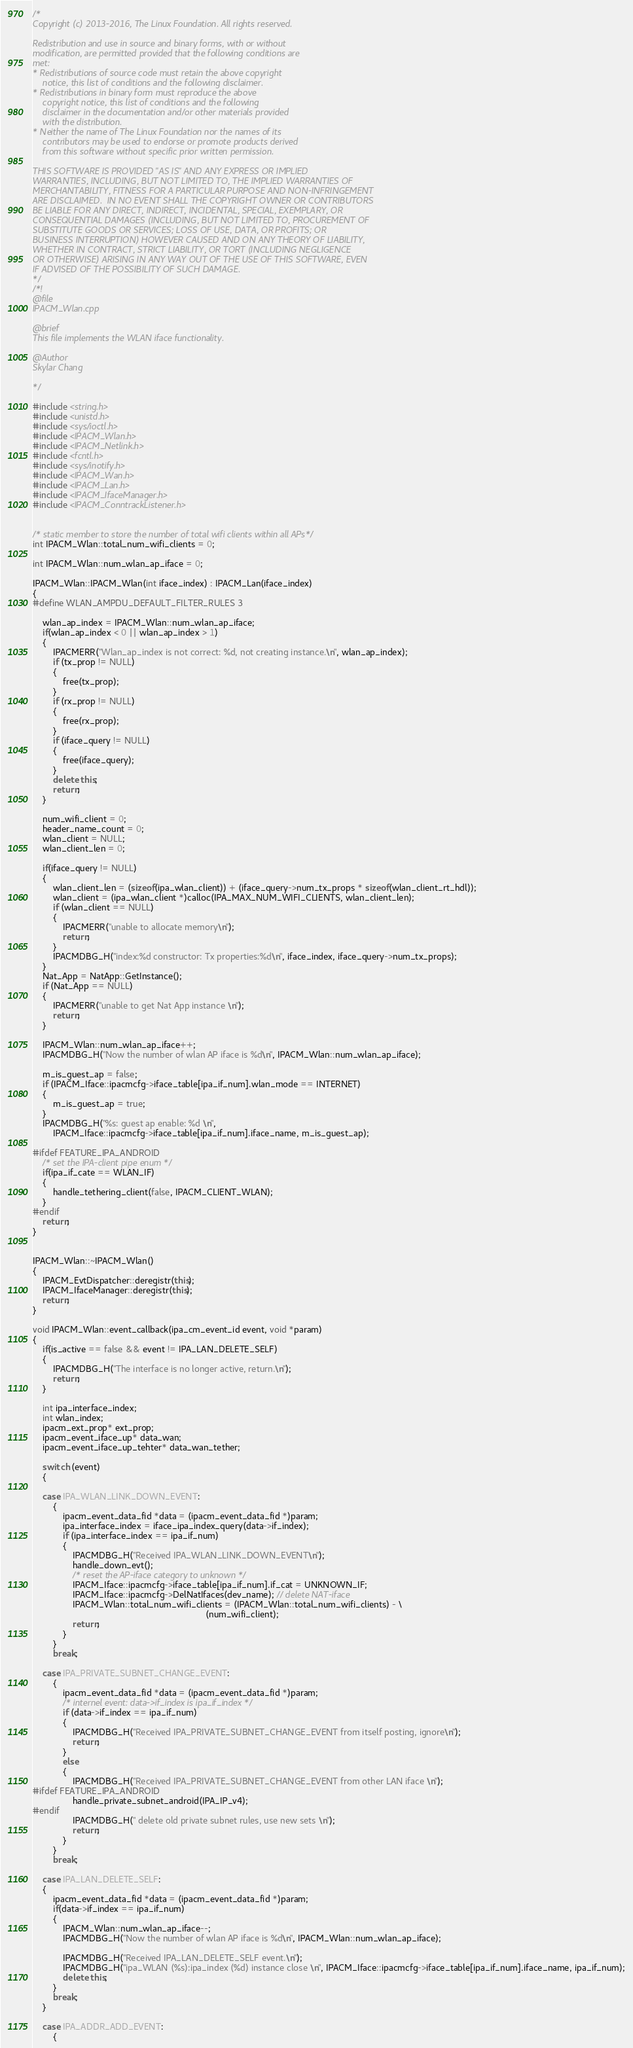Convert code to text. <code><loc_0><loc_0><loc_500><loc_500><_C++_>/*
Copyright (c) 2013-2016, The Linux Foundation. All rights reserved.

Redistribution and use in source and binary forms, with or without
modification, are permitted provided that the following conditions are
met:
* Redistributions of source code must retain the above copyright
	notice, this list of conditions and the following disclaimer.
* Redistributions in binary form must reproduce the above
	copyright notice, this list of conditions and the following
	disclaimer in the documentation and/or other materials provided
	with the distribution.
* Neither the name of The Linux Foundation nor the names of its
	contributors may be used to endorse or promote products derived
	from this software without specific prior written permission.

THIS SOFTWARE IS PROVIDED "AS IS" AND ANY EXPRESS OR IMPLIED
WARRANTIES, INCLUDING, BUT NOT LIMITED TO, THE IMPLIED WARRANTIES OF
MERCHANTABILITY, FITNESS FOR A PARTICULAR PURPOSE AND NON-INFRINGEMENT
ARE DISCLAIMED.  IN NO EVENT SHALL THE COPYRIGHT OWNER OR CONTRIBUTORS
BE LIABLE FOR ANY DIRECT, INDIRECT, INCIDENTAL, SPECIAL, EXEMPLARY, OR
CONSEQUENTIAL DAMAGES (INCLUDING, BUT NOT LIMITED TO, PROCUREMENT OF
SUBSTITUTE GOODS OR SERVICES; LOSS OF USE, DATA, OR PROFITS; OR
BUSINESS INTERRUPTION) HOWEVER CAUSED AND ON ANY THEORY OF LIABILITY,
WHETHER IN CONTRACT, STRICT LIABILITY, OR TORT (INCLUDING NEGLIGENCE
OR OTHERWISE) ARISING IN ANY WAY OUT OF THE USE OF THIS SOFTWARE, EVEN
IF ADVISED OF THE POSSIBILITY OF SUCH DAMAGE.
*/
/*!
@file
IPACM_Wlan.cpp

@brief
This file implements the WLAN iface functionality.

@Author
Skylar Chang

*/

#include <string.h>
#include <unistd.h>
#include <sys/ioctl.h>
#include <IPACM_Wlan.h>
#include <IPACM_Netlink.h>
#include <fcntl.h>
#include <sys/inotify.h>
#include <IPACM_Wan.h>
#include <IPACM_Lan.h>
#include <IPACM_IfaceManager.h>
#include <IPACM_ConntrackListener.h>


/* static member to store the number of total wifi clients within all APs*/
int IPACM_Wlan::total_num_wifi_clients = 0;

int IPACM_Wlan::num_wlan_ap_iface = 0;

IPACM_Wlan::IPACM_Wlan(int iface_index) : IPACM_Lan(iface_index)
{
#define WLAN_AMPDU_DEFAULT_FILTER_RULES 3

	wlan_ap_index = IPACM_Wlan::num_wlan_ap_iface;
	if(wlan_ap_index < 0 || wlan_ap_index > 1)
	{
		IPACMERR("Wlan_ap_index is not correct: %d, not creating instance.\n", wlan_ap_index);
		if (tx_prop != NULL)
		{
			free(tx_prop);
		}
		if (rx_prop != NULL)
		{
			free(rx_prop);
		}
		if (iface_query != NULL)
		{
			free(iface_query);
		}
		delete this;
		return;
	}

	num_wifi_client = 0;
	header_name_count = 0;
	wlan_client = NULL;
	wlan_client_len = 0;

	if(iface_query != NULL)
	{
		wlan_client_len = (sizeof(ipa_wlan_client)) + (iface_query->num_tx_props * sizeof(wlan_client_rt_hdl));
		wlan_client = (ipa_wlan_client *)calloc(IPA_MAX_NUM_WIFI_CLIENTS, wlan_client_len);
		if (wlan_client == NULL)
		{
			IPACMERR("unable to allocate memory\n");
			return;
		}
		IPACMDBG_H("index:%d constructor: Tx properties:%d\n", iface_index, iface_query->num_tx_props);
	}
	Nat_App = NatApp::GetInstance();
	if (Nat_App == NULL)
	{
		IPACMERR("unable to get Nat App instance \n");
		return;
	}

	IPACM_Wlan::num_wlan_ap_iface++;
	IPACMDBG_H("Now the number of wlan AP iface is %d\n", IPACM_Wlan::num_wlan_ap_iface);

	m_is_guest_ap = false;
	if (IPACM_Iface::ipacmcfg->iface_table[ipa_if_num].wlan_mode == INTERNET)
	{
		m_is_guest_ap = true;
	}
	IPACMDBG_H("%s: guest ap enable: %d \n",
		IPACM_Iface::ipacmcfg->iface_table[ipa_if_num].iface_name, m_is_guest_ap);

#ifdef FEATURE_IPA_ANDROID
	/* set the IPA-client pipe enum */
	if(ipa_if_cate == WLAN_IF)
	{
		handle_tethering_client(false, IPACM_CLIENT_WLAN);
	}
#endif
	return;
}


IPACM_Wlan::~IPACM_Wlan()
{
	IPACM_EvtDispatcher::deregistr(this);
	IPACM_IfaceManager::deregistr(this);
	return;
}

void IPACM_Wlan::event_callback(ipa_cm_event_id event, void *param)
{
	if(is_active == false && event != IPA_LAN_DELETE_SELF)
	{
		IPACMDBG_H("The interface is no longer active, return.\n");
		return;
	}

	int ipa_interface_index;
	int wlan_index;
	ipacm_ext_prop* ext_prop;
	ipacm_event_iface_up* data_wan;
	ipacm_event_iface_up_tehter* data_wan_tether;

	switch (event)
	{

	case IPA_WLAN_LINK_DOWN_EVENT:
		{
			ipacm_event_data_fid *data = (ipacm_event_data_fid *)param;
			ipa_interface_index = iface_ipa_index_query(data->if_index);
			if (ipa_interface_index == ipa_if_num)
			{
				IPACMDBG_H("Received IPA_WLAN_LINK_DOWN_EVENT\n");
				handle_down_evt();
				/* reset the AP-iface category to unknown */
				IPACM_Iface::ipacmcfg->iface_table[ipa_if_num].if_cat = UNKNOWN_IF;
				IPACM_Iface::ipacmcfg->DelNatIfaces(dev_name); // delete NAT-iface
				IPACM_Wlan::total_num_wifi_clients = (IPACM_Wlan::total_num_wifi_clients) - \
                                                                     (num_wifi_client);
				return;
			}
		}
		break;

	case IPA_PRIVATE_SUBNET_CHANGE_EVENT:
		{
			ipacm_event_data_fid *data = (ipacm_event_data_fid *)param;
			/* internel event: data->if_index is ipa_if_index */
			if (data->if_index == ipa_if_num)
			{
				IPACMDBG_H("Received IPA_PRIVATE_SUBNET_CHANGE_EVENT from itself posting, ignore\n");
				return;
			}
			else
			{
				IPACMDBG_H("Received IPA_PRIVATE_SUBNET_CHANGE_EVENT from other LAN iface \n");
#ifdef FEATURE_IPA_ANDROID
				handle_private_subnet_android(IPA_IP_v4);
#endif
				IPACMDBG_H(" delete old private subnet rules, use new sets \n");
				return;
			}
		}
		break;

	case IPA_LAN_DELETE_SELF:
	{
		ipacm_event_data_fid *data = (ipacm_event_data_fid *)param;
		if(data->if_index == ipa_if_num)
		{
			IPACM_Wlan::num_wlan_ap_iface--;
			IPACMDBG_H("Now the number of wlan AP iface is %d\n", IPACM_Wlan::num_wlan_ap_iface);

			IPACMDBG_H("Received IPA_LAN_DELETE_SELF event.\n");
			IPACMDBG_H("ipa_WLAN (%s):ipa_index (%d) instance close \n", IPACM_Iface::ipacmcfg->iface_table[ipa_if_num].iface_name, ipa_if_num);
			delete this;
		}
		break;
	}

	case IPA_ADDR_ADD_EVENT:
		{</code> 